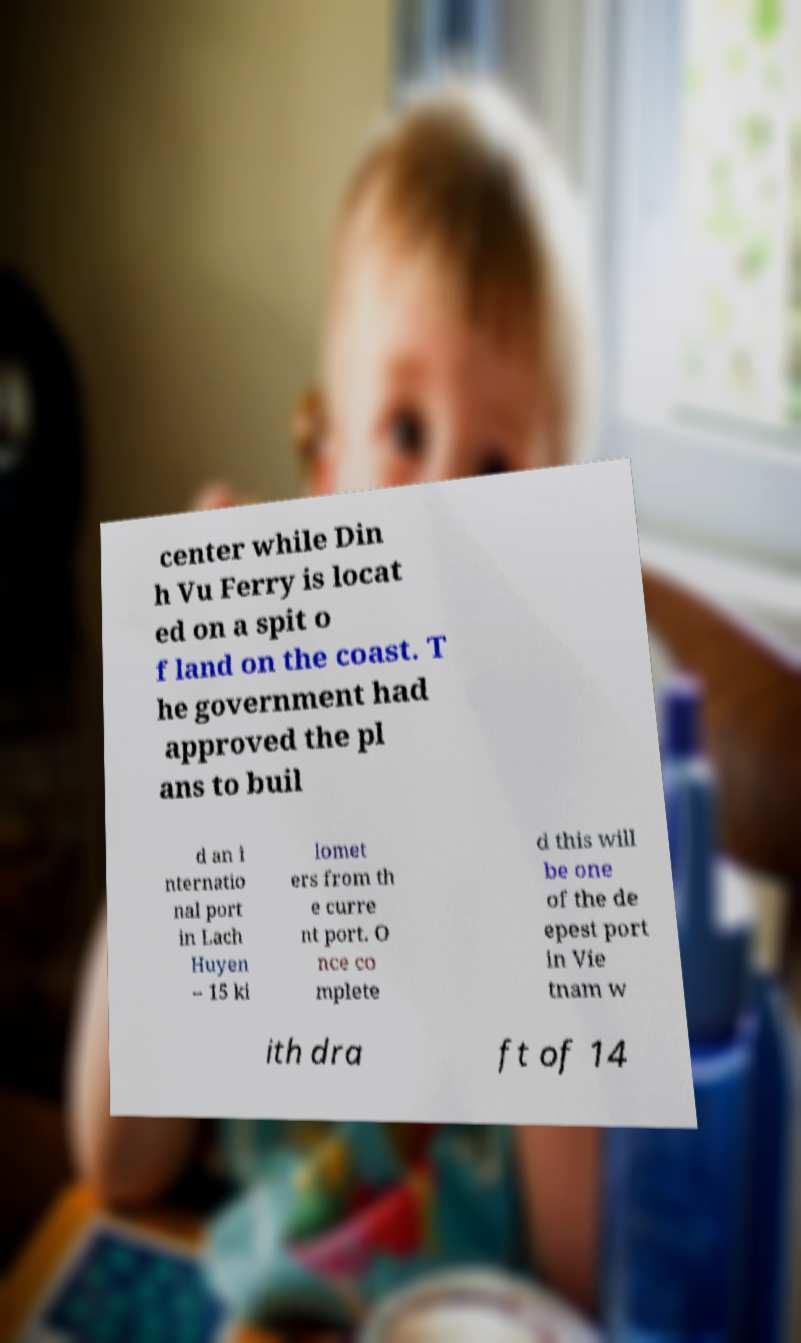Could you assist in decoding the text presented in this image and type it out clearly? center while Din h Vu Ferry is locat ed on a spit o f land on the coast. T he government had approved the pl ans to buil d an i nternatio nal port in Lach Huyen – 15 ki lomet ers from th e curre nt port. O nce co mplete d this will be one of the de epest port in Vie tnam w ith dra ft of 14 